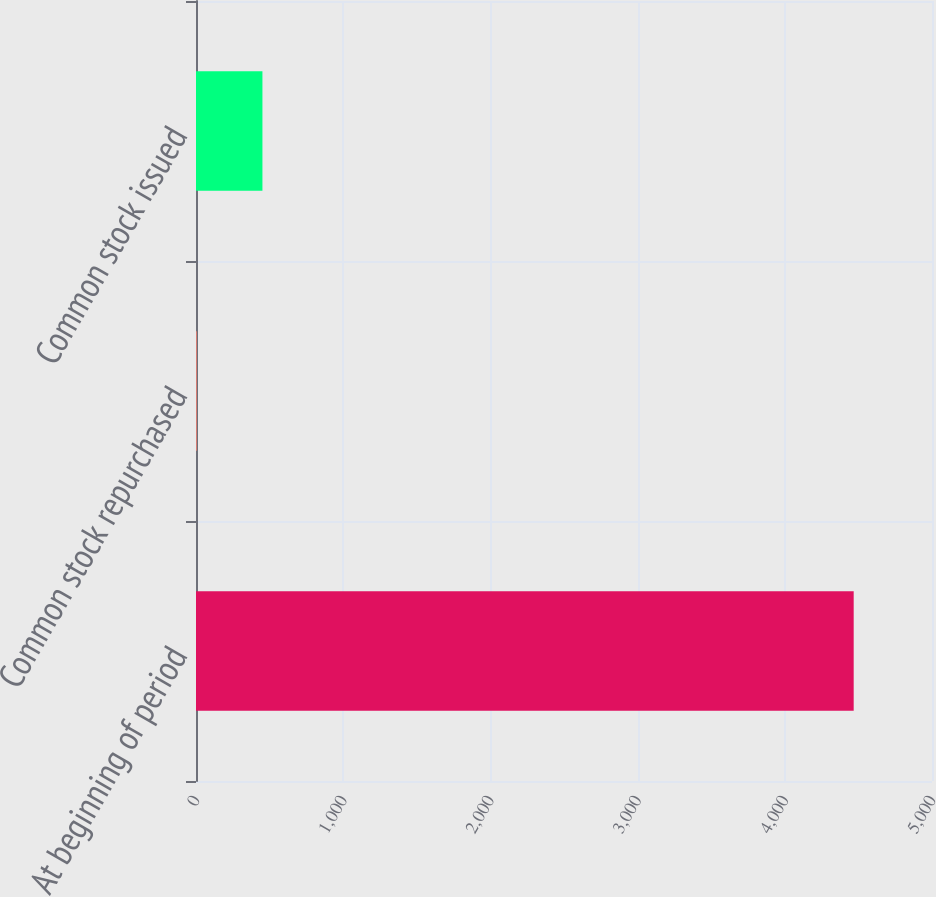Convert chart to OTSL. <chart><loc_0><loc_0><loc_500><loc_500><bar_chart><fcel>At beginning of period<fcel>Common stock repurchased<fcel>Common stock issued<nl><fcel>4468<fcel>5<fcel>451.3<nl></chart> 